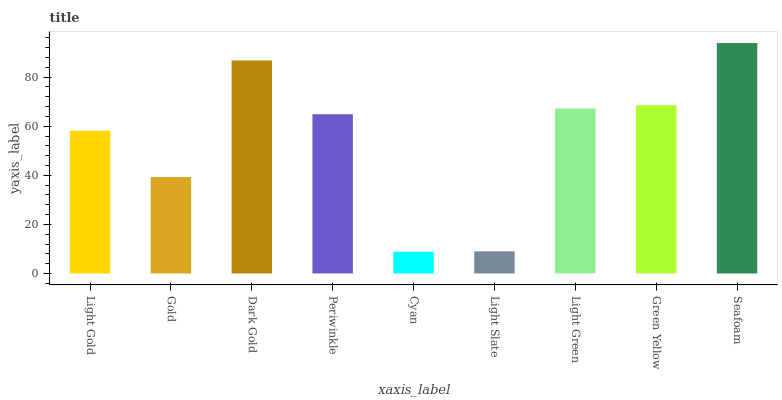Is Gold the minimum?
Answer yes or no. No. Is Gold the maximum?
Answer yes or no. No. Is Light Gold greater than Gold?
Answer yes or no. Yes. Is Gold less than Light Gold?
Answer yes or no. Yes. Is Gold greater than Light Gold?
Answer yes or no. No. Is Light Gold less than Gold?
Answer yes or no. No. Is Periwinkle the high median?
Answer yes or no. Yes. Is Periwinkle the low median?
Answer yes or no. Yes. Is Light Green the high median?
Answer yes or no. No. Is Light Green the low median?
Answer yes or no. No. 